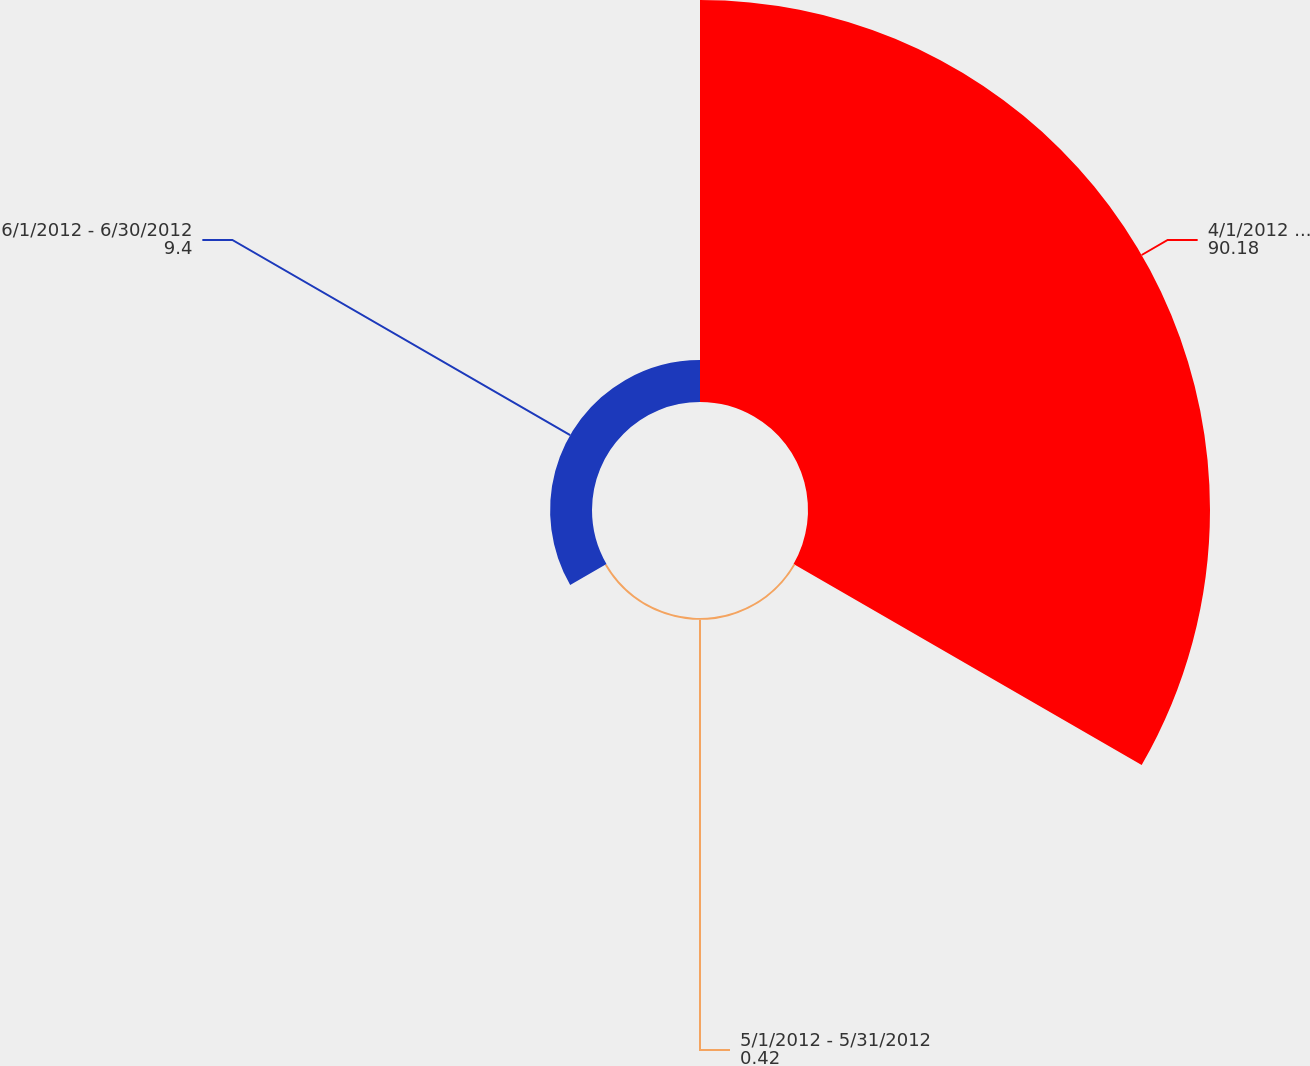Convert chart to OTSL. <chart><loc_0><loc_0><loc_500><loc_500><pie_chart><fcel>4/1/2012 - 4/30/2012<fcel>5/1/2012 - 5/31/2012<fcel>6/1/2012 - 6/30/2012<nl><fcel>90.18%<fcel>0.42%<fcel>9.4%<nl></chart> 